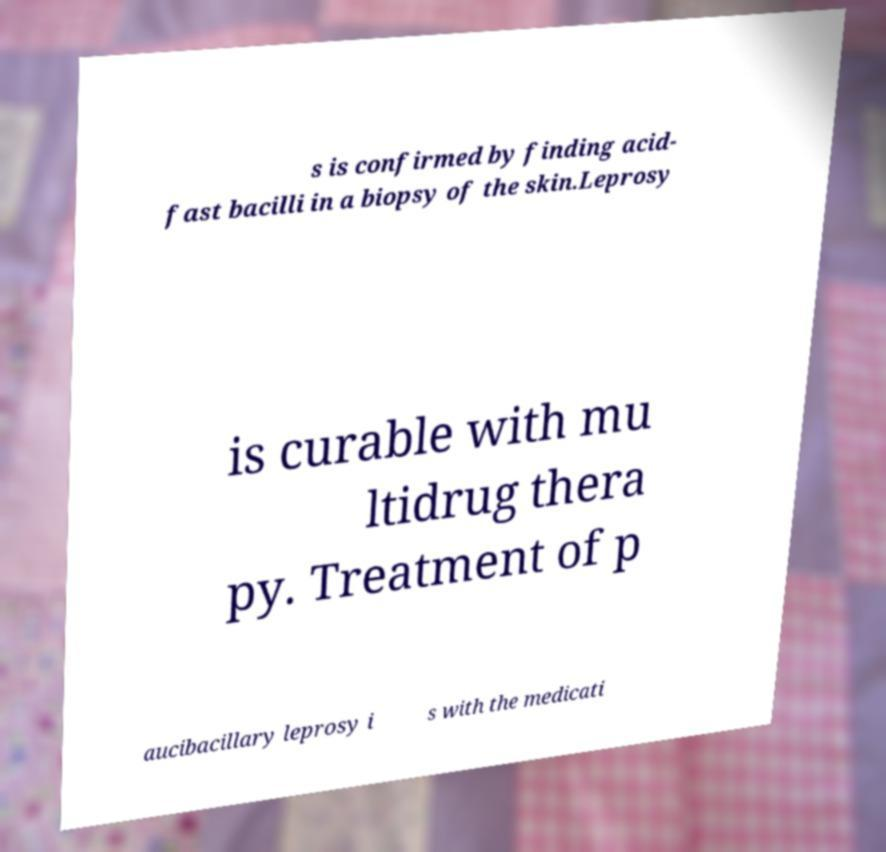For documentation purposes, I need the text within this image transcribed. Could you provide that? s is confirmed by finding acid- fast bacilli in a biopsy of the skin.Leprosy is curable with mu ltidrug thera py. Treatment of p aucibacillary leprosy i s with the medicati 